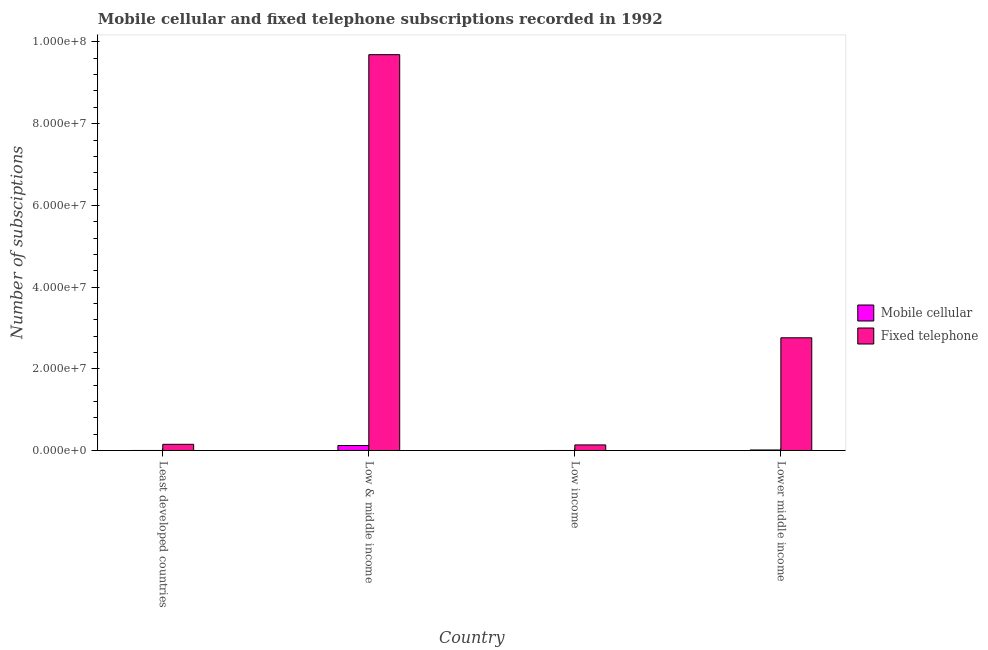How many different coloured bars are there?
Offer a very short reply. 2. Are the number of bars per tick equal to the number of legend labels?
Keep it short and to the point. Yes. What is the label of the 2nd group of bars from the left?
Offer a very short reply. Low & middle income. What is the number of mobile cellular subscriptions in Low & middle income?
Offer a terse response. 1.23e+06. Across all countries, what is the maximum number of fixed telephone subscriptions?
Offer a very short reply. 9.69e+07. Across all countries, what is the minimum number of mobile cellular subscriptions?
Your answer should be compact. 204. In which country was the number of fixed telephone subscriptions minimum?
Provide a short and direct response. Low income. What is the total number of fixed telephone subscriptions in the graph?
Make the answer very short. 1.27e+08. What is the difference between the number of fixed telephone subscriptions in Low income and that in Lower middle income?
Make the answer very short. -2.62e+07. What is the difference between the number of mobile cellular subscriptions in Low income and the number of fixed telephone subscriptions in Low & middle income?
Give a very brief answer. -9.69e+07. What is the average number of mobile cellular subscriptions per country?
Your answer should be compact. 3.38e+05. What is the difference between the number of mobile cellular subscriptions and number of fixed telephone subscriptions in Lower middle income?
Your answer should be compact. -2.75e+07. What is the ratio of the number of fixed telephone subscriptions in Least developed countries to that in Low & middle income?
Make the answer very short. 0.02. Is the number of fixed telephone subscriptions in Low & middle income less than that in Lower middle income?
Offer a very short reply. No. What is the difference between the highest and the second highest number of fixed telephone subscriptions?
Give a very brief answer. 6.93e+07. What is the difference between the highest and the lowest number of fixed telephone subscriptions?
Offer a very short reply. 9.55e+07. In how many countries, is the number of fixed telephone subscriptions greater than the average number of fixed telephone subscriptions taken over all countries?
Your answer should be compact. 1. What does the 1st bar from the left in Low income represents?
Your answer should be very brief. Mobile cellular. What does the 1st bar from the right in Least developed countries represents?
Make the answer very short. Fixed telephone. How many bars are there?
Provide a succinct answer. 8. Are all the bars in the graph horizontal?
Your answer should be compact. No. How many countries are there in the graph?
Your answer should be very brief. 4. What is the difference between two consecutive major ticks on the Y-axis?
Provide a succinct answer. 2.00e+07. Are the values on the major ticks of Y-axis written in scientific E-notation?
Keep it short and to the point. Yes. Does the graph contain any zero values?
Offer a terse response. No. Does the graph contain grids?
Provide a short and direct response. No. Where does the legend appear in the graph?
Your answer should be very brief. Center right. How many legend labels are there?
Your answer should be very brief. 2. What is the title of the graph?
Keep it short and to the point. Mobile cellular and fixed telephone subscriptions recorded in 1992. What is the label or title of the X-axis?
Give a very brief answer. Country. What is the label or title of the Y-axis?
Provide a succinct answer. Number of subsciptions. What is the Number of subsciptions of Mobile cellular in Least developed countries?
Give a very brief answer. 2294. What is the Number of subsciptions of Fixed telephone in Least developed countries?
Keep it short and to the point. 1.51e+06. What is the Number of subsciptions in Mobile cellular in Low & middle income?
Give a very brief answer. 1.23e+06. What is the Number of subsciptions of Fixed telephone in Low & middle income?
Provide a short and direct response. 9.69e+07. What is the Number of subsciptions in Mobile cellular in Low income?
Offer a very short reply. 204. What is the Number of subsciptions of Fixed telephone in Low income?
Make the answer very short. 1.36e+06. What is the Number of subsciptions in Mobile cellular in Lower middle income?
Your answer should be very brief. 1.25e+05. What is the Number of subsciptions of Fixed telephone in Lower middle income?
Keep it short and to the point. 2.76e+07. Across all countries, what is the maximum Number of subsciptions of Mobile cellular?
Offer a very short reply. 1.23e+06. Across all countries, what is the maximum Number of subsciptions of Fixed telephone?
Your answer should be compact. 9.69e+07. Across all countries, what is the minimum Number of subsciptions of Mobile cellular?
Provide a short and direct response. 204. Across all countries, what is the minimum Number of subsciptions in Fixed telephone?
Offer a very short reply. 1.36e+06. What is the total Number of subsciptions in Mobile cellular in the graph?
Give a very brief answer. 1.35e+06. What is the total Number of subsciptions of Fixed telephone in the graph?
Provide a succinct answer. 1.27e+08. What is the difference between the Number of subsciptions of Mobile cellular in Least developed countries and that in Low & middle income?
Provide a short and direct response. -1.22e+06. What is the difference between the Number of subsciptions in Fixed telephone in Least developed countries and that in Low & middle income?
Provide a short and direct response. -9.54e+07. What is the difference between the Number of subsciptions in Mobile cellular in Least developed countries and that in Low income?
Your answer should be compact. 2090. What is the difference between the Number of subsciptions in Fixed telephone in Least developed countries and that in Low income?
Keep it short and to the point. 1.45e+05. What is the difference between the Number of subsciptions of Mobile cellular in Least developed countries and that in Lower middle income?
Give a very brief answer. -1.22e+05. What is the difference between the Number of subsciptions of Fixed telephone in Least developed countries and that in Lower middle income?
Ensure brevity in your answer.  -2.61e+07. What is the difference between the Number of subsciptions in Mobile cellular in Low & middle income and that in Low income?
Provide a succinct answer. 1.22e+06. What is the difference between the Number of subsciptions of Fixed telephone in Low & middle income and that in Low income?
Give a very brief answer. 9.55e+07. What is the difference between the Number of subsciptions of Mobile cellular in Low & middle income and that in Lower middle income?
Offer a very short reply. 1.10e+06. What is the difference between the Number of subsciptions of Fixed telephone in Low & middle income and that in Lower middle income?
Offer a terse response. 6.93e+07. What is the difference between the Number of subsciptions of Mobile cellular in Low income and that in Lower middle income?
Give a very brief answer. -1.25e+05. What is the difference between the Number of subsciptions of Fixed telephone in Low income and that in Lower middle income?
Give a very brief answer. -2.62e+07. What is the difference between the Number of subsciptions in Mobile cellular in Least developed countries and the Number of subsciptions in Fixed telephone in Low & middle income?
Your answer should be compact. -9.69e+07. What is the difference between the Number of subsciptions of Mobile cellular in Least developed countries and the Number of subsciptions of Fixed telephone in Low income?
Offer a terse response. -1.36e+06. What is the difference between the Number of subsciptions of Mobile cellular in Least developed countries and the Number of subsciptions of Fixed telephone in Lower middle income?
Your answer should be very brief. -2.76e+07. What is the difference between the Number of subsciptions in Mobile cellular in Low & middle income and the Number of subsciptions in Fixed telephone in Low income?
Give a very brief answer. -1.37e+05. What is the difference between the Number of subsciptions of Mobile cellular in Low & middle income and the Number of subsciptions of Fixed telephone in Lower middle income?
Give a very brief answer. -2.64e+07. What is the difference between the Number of subsciptions of Mobile cellular in Low income and the Number of subsciptions of Fixed telephone in Lower middle income?
Your answer should be compact. -2.76e+07. What is the average Number of subsciptions in Mobile cellular per country?
Your answer should be compact. 3.38e+05. What is the average Number of subsciptions in Fixed telephone per country?
Your answer should be compact. 3.18e+07. What is the difference between the Number of subsciptions in Mobile cellular and Number of subsciptions in Fixed telephone in Least developed countries?
Your answer should be very brief. -1.51e+06. What is the difference between the Number of subsciptions in Mobile cellular and Number of subsciptions in Fixed telephone in Low & middle income?
Your answer should be compact. -9.57e+07. What is the difference between the Number of subsciptions of Mobile cellular and Number of subsciptions of Fixed telephone in Low income?
Your response must be concise. -1.36e+06. What is the difference between the Number of subsciptions in Mobile cellular and Number of subsciptions in Fixed telephone in Lower middle income?
Provide a short and direct response. -2.75e+07. What is the ratio of the Number of subsciptions of Mobile cellular in Least developed countries to that in Low & middle income?
Your response must be concise. 0. What is the ratio of the Number of subsciptions in Fixed telephone in Least developed countries to that in Low & middle income?
Your answer should be compact. 0.02. What is the ratio of the Number of subsciptions of Mobile cellular in Least developed countries to that in Low income?
Offer a terse response. 11.25. What is the ratio of the Number of subsciptions in Fixed telephone in Least developed countries to that in Low income?
Keep it short and to the point. 1.11. What is the ratio of the Number of subsciptions in Mobile cellular in Least developed countries to that in Lower middle income?
Your response must be concise. 0.02. What is the ratio of the Number of subsciptions of Fixed telephone in Least developed countries to that in Lower middle income?
Offer a terse response. 0.05. What is the ratio of the Number of subsciptions in Mobile cellular in Low & middle income to that in Low income?
Ensure brevity in your answer.  6005.46. What is the ratio of the Number of subsciptions in Fixed telephone in Low & middle income to that in Low income?
Keep it short and to the point. 71.13. What is the ratio of the Number of subsciptions in Mobile cellular in Low & middle income to that in Lower middle income?
Your answer should be compact. 9.82. What is the ratio of the Number of subsciptions of Fixed telephone in Low & middle income to that in Lower middle income?
Provide a succinct answer. 3.51. What is the ratio of the Number of subsciptions in Mobile cellular in Low income to that in Lower middle income?
Your answer should be very brief. 0. What is the ratio of the Number of subsciptions of Fixed telephone in Low income to that in Lower middle income?
Give a very brief answer. 0.05. What is the difference between the highest and the second highest Number of subsciptions of Mobile cellular?
Keep it short and to the point. 1.10e+06. What is the difference between the highest and the second highest Number of subsciptions in Fixed telephone?
Ensure brevity in your answer.  6.93e+07. What is the difference between the highest and the lowest Number of subsciptions of Mobile cellular?
Keep it short and to the point. 1.22e+06. What is the difference between the highest and the lowest Number of subsciptions in Fixed telephone?
Make the answer very short. 9.55e+07. 